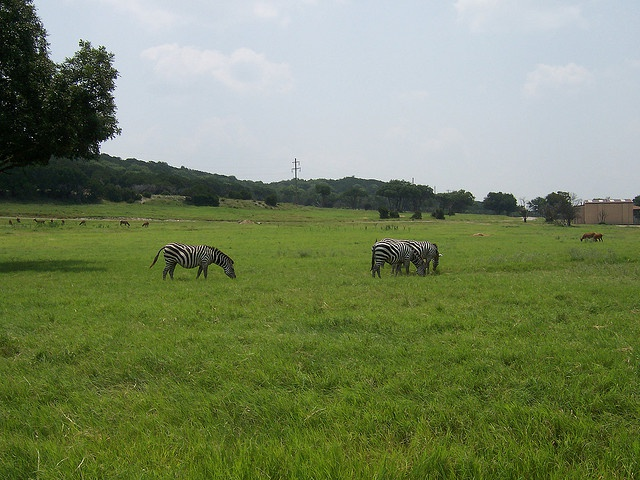Describe the objects in this image and their specific colors. I can see zebra in black, darkgreen, gray, and olive tones, zebra in black, gray, darkgreen, and darkgray tones, and zebra in black, gray, darkgreen, and olive tones in this image. 